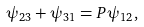<formula> <loc_0><loc_0><loc_500><loc_500>\psi _ { 2 3 } + \psi _ { 3 1 } = P \psi _ { 1 2 } ,</formula> 